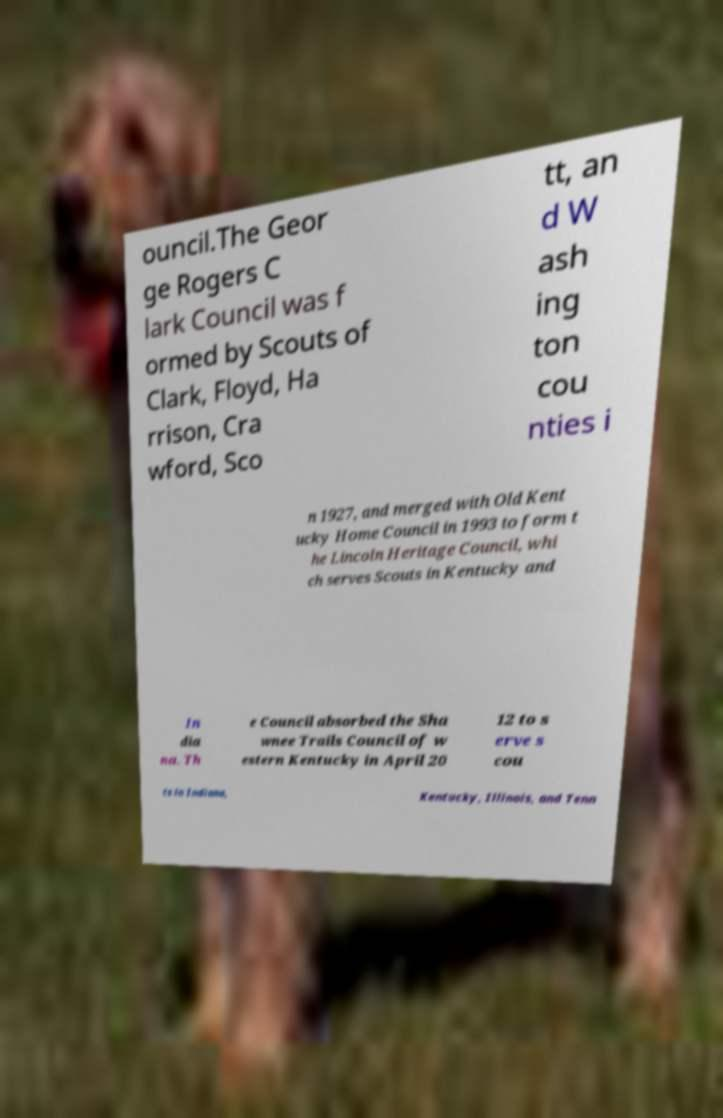There's text embedded in this image that I need extracted. Can you transcribe it verbatim? ouncil.The Geor ge Rogers C lark Council was f ormed by Scouts of Clark, Floyd, Ha rrison, Cra wford, Sco tt, an d W ash ing ton cou nties i n 1927, and merged with Old Kent ucky Home Council in 1993 to form t he Lincoln Heritage Council, whi ch serves Scouts in Kentucky and In dia na. Th e Council absorbed the Sha wnee Trails Council of w estern Kentucky in April 20 12 to s erve s cou ts in Indiana, Kentucky, Illinois, and Tenn 